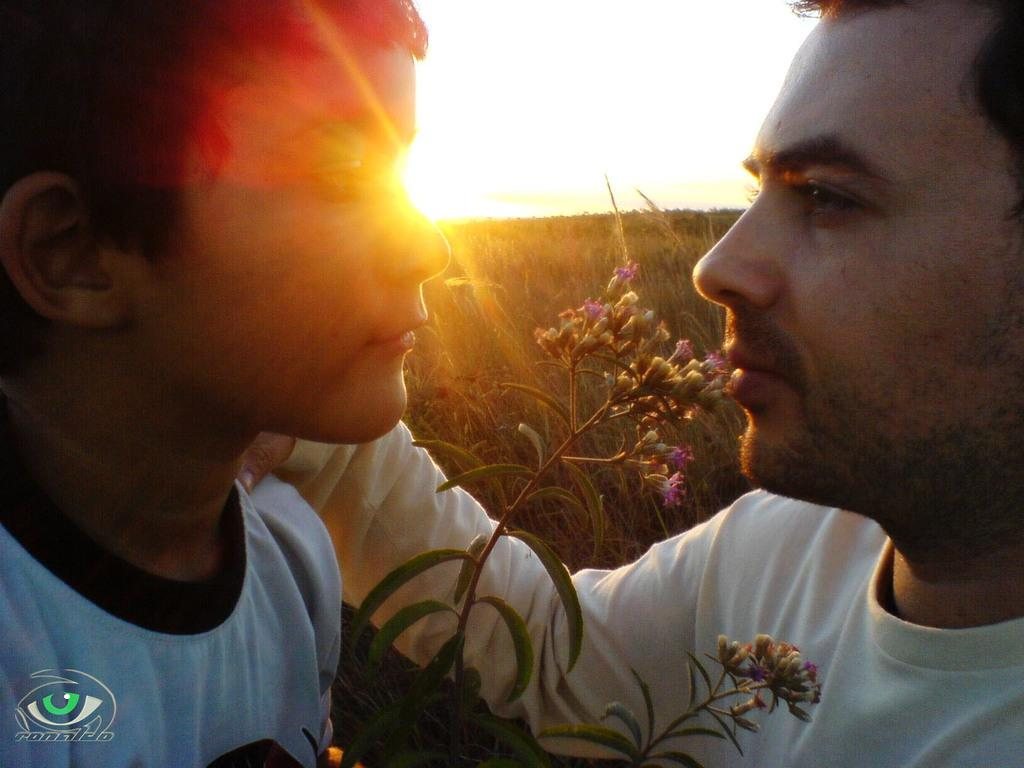Who is present in the image? There is a person and a kid in the image. What are the person and the kid wearing? Both the person and the kid are wearing clothes. What can be seen at the bottom of the image? There is a plant at the bottom of the image. What is visible at the top of the image? The sky is visible at the top of the image. How many balls are being juggled by the person in the image? There are no balls present in the image, and the person is not juggling anything. What type of rock is visible in the image? There is no rock present in the image. 